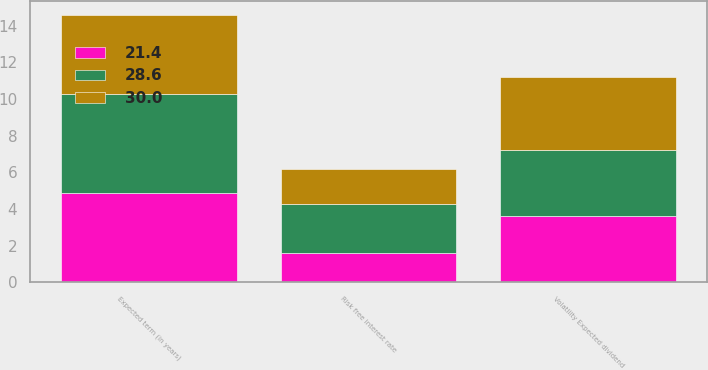Convert chart to OTSL. <chart><loc_0><loc_0><loc_500><loc_500><stacked_bar_chart><ecel><fcel>Volatility Expected dividend<fcel>Expected term (in years)<fcel>Risk free interest rate<nl><fcel>30<fcel>4<fcel>4.3<fcel>1.9<nl><fcel>21.4<fcel>3.6<fcel>4.9<fcel>1.6<nl><fcel>28.6<fcel>3.6<fcel>5.4<fcel>2.7<nl></chart> 